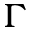Convert formula to latex. <formula><loc_0><loc_0><loc_500><loc_500>\Gamma</formula> 